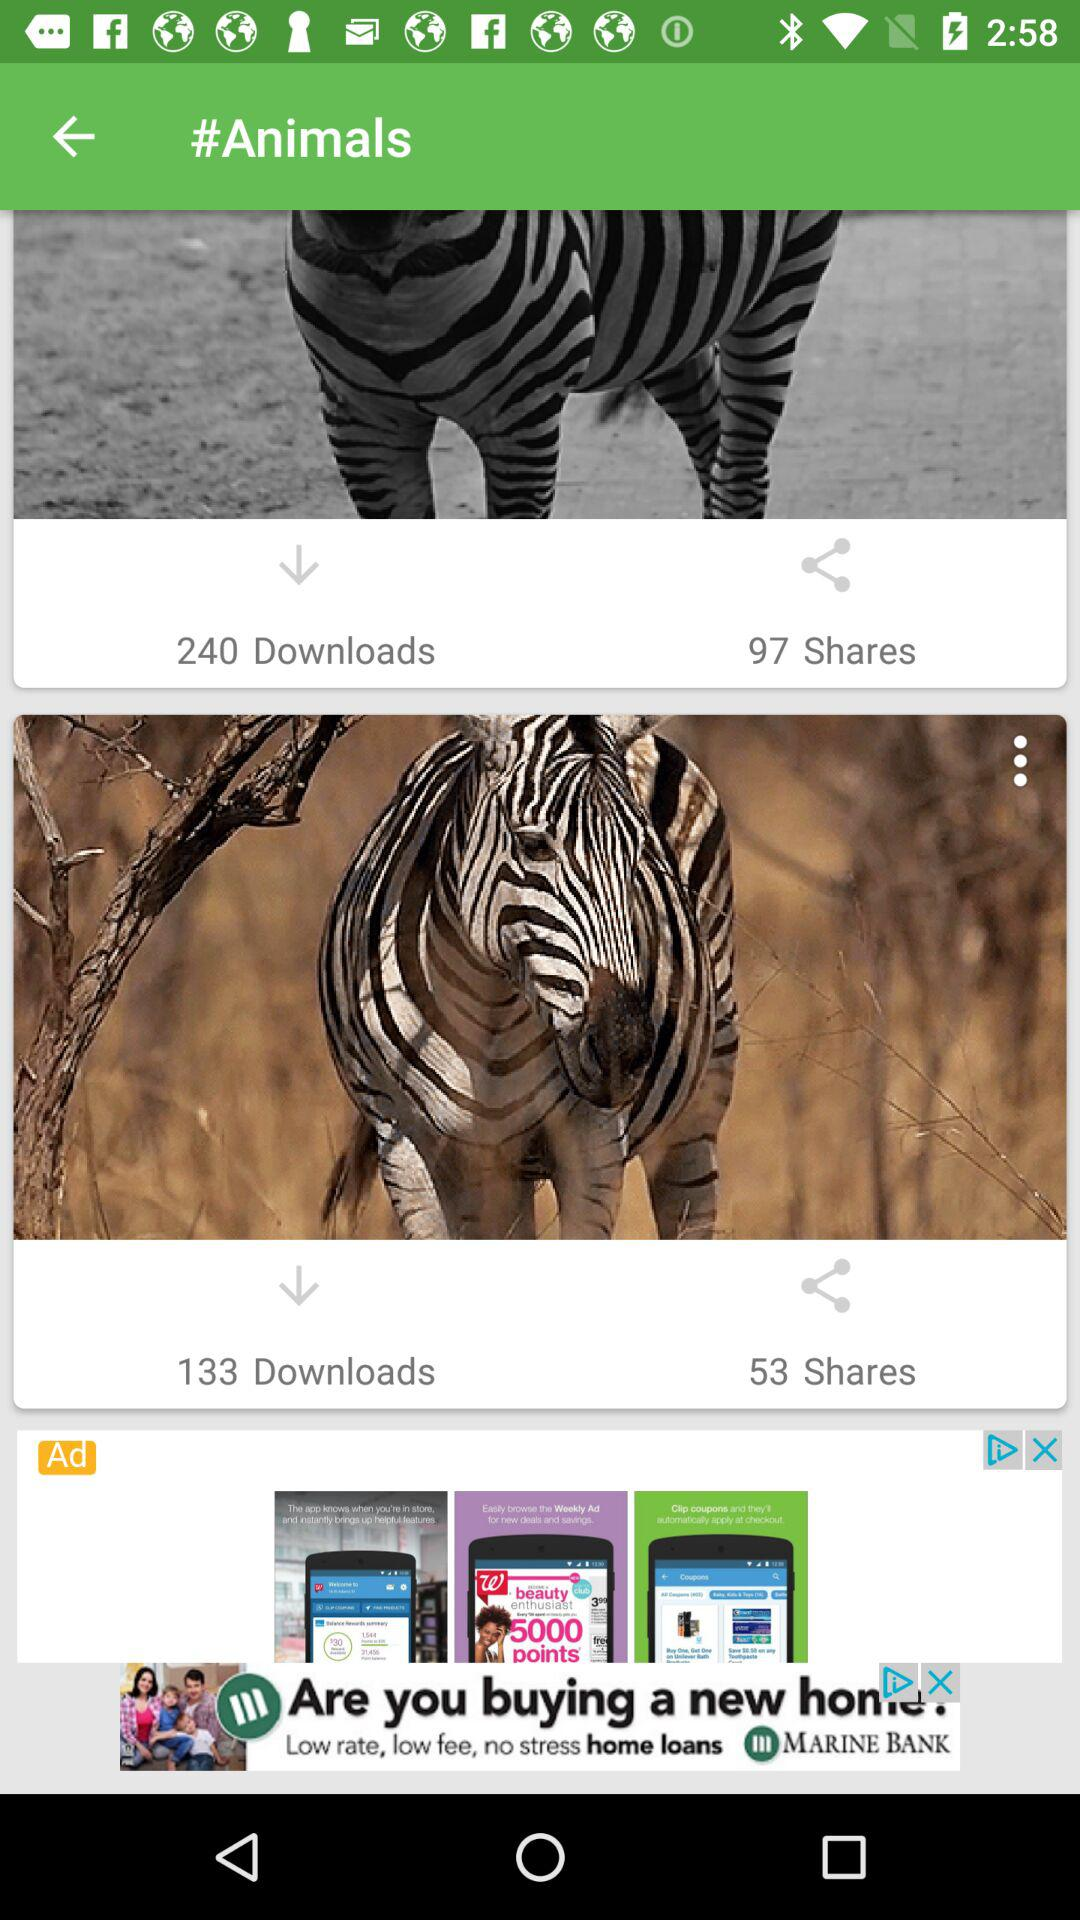How many more shares does the zebra standing on a dirt road have than the zebra standing in the grass?
Answer the question using a single word or phrase. 44 